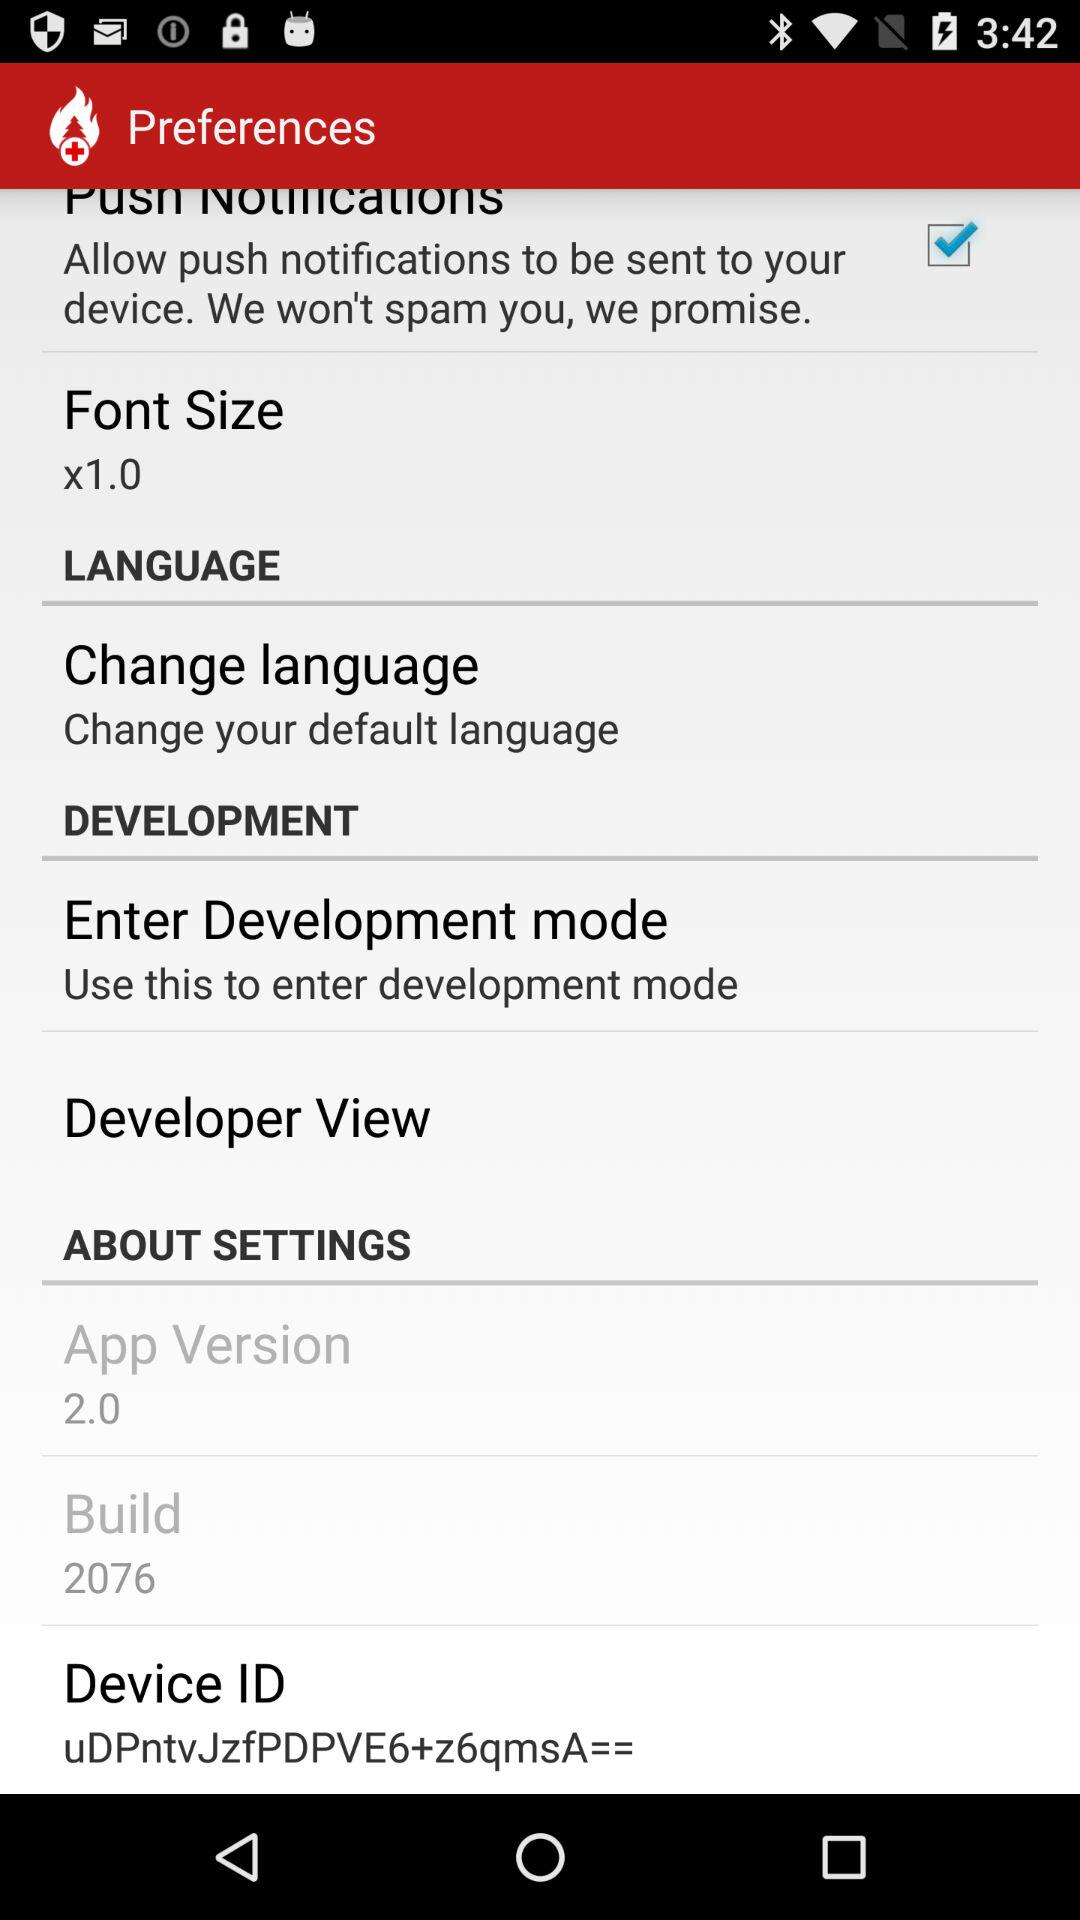What is the version of the application? The version of the application is 2.0. 